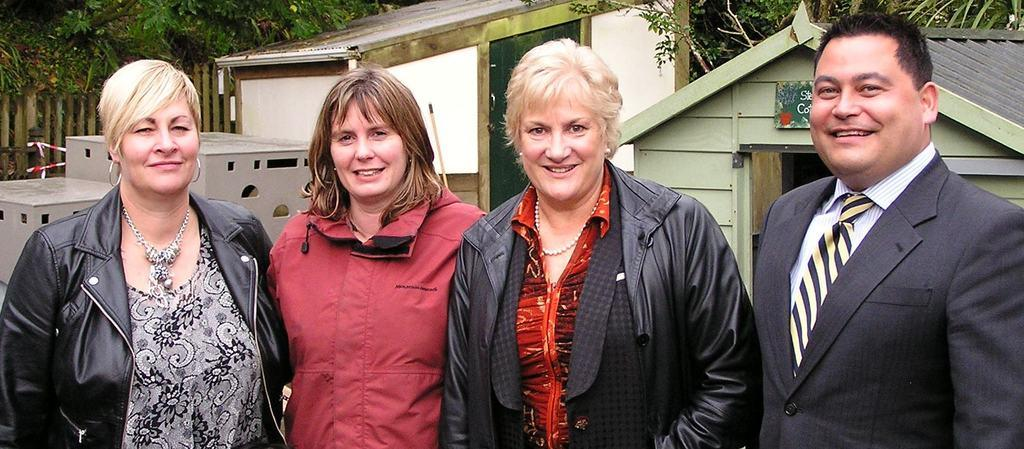How many people are present in the image? There are four people in the image. What can be seen in the background of the image? There is a house, a fence, and trees in the background. What direction is the needle pointing in the image? There is no needle present in the image. 